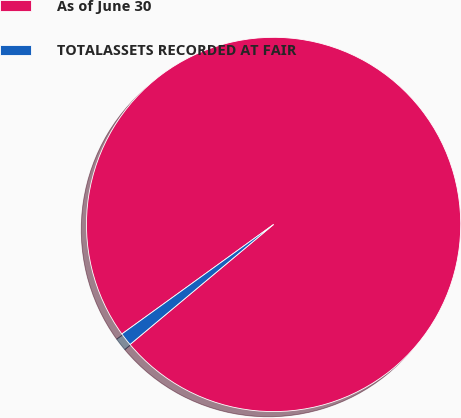Convert chart to OTSL. <chart><loc_0><loc_0><loc_500><loc_500><pie_chart><fcel>As of June 30<fcel>TOTALASSETS RECORDED AT FAIR<nl><fcel>98.87%<fcel>1.13%<nl></chart> 